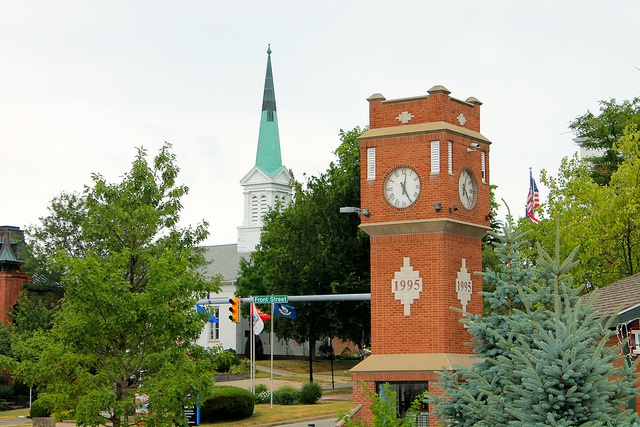Describe the objects in this image and their specific colors. I can see clock in white, lightgray, darkgray, and gray tones, clock in white, darkgray, and gray tones, and traffic light in white, orange, black, red, and olive tones in this image. 